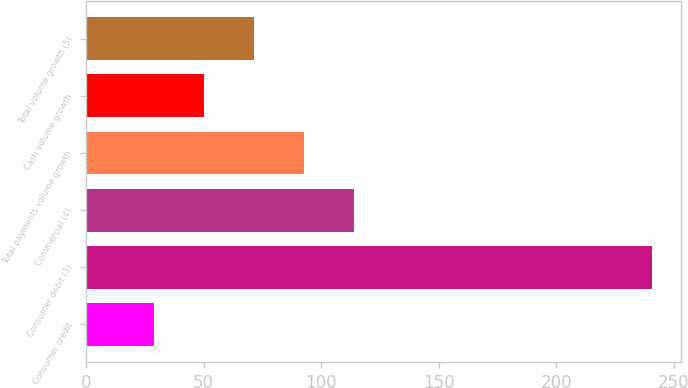<chart> <loc_0><loc_0><loc_500><loc_500><bar_chart><fcel>Consumer credit<fcel>Consumer debit (3)<fcel>Commercial (4)<fcel>Total payments volume growth<fcel>Cash volume growth<fcel>Total volume growth (5)<nl><fcel>29<fcel>241<fcel>113.8<fcel>92.6<fcel>50.2<fcel>71.4<nl></chart> 